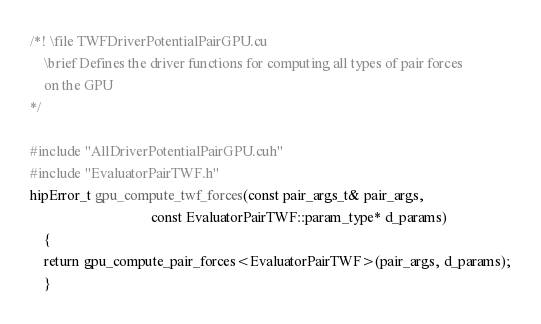<code> <loc_0><loc_0><loc_500><loc_500><_Cuda_>/*! \file TWFDriverPotentialPairGPU.cu
    \brief Defines the driver functions for computing all types of pair forces
    on the GPU
*/

#include "AllDriverPotentialPairGPU.cuh"
#include "EvaluatorPairTWF.h"
hipError_t gpu_compute_twf_forces(const pair_args_t& pair_args,
                                  const EvaluatorPairTWF::param_type* d_params)
    {
    return gpu_compute_pair_forces<EvaluatorPairTWF>(pair_args, d_params);
    }
</code> 